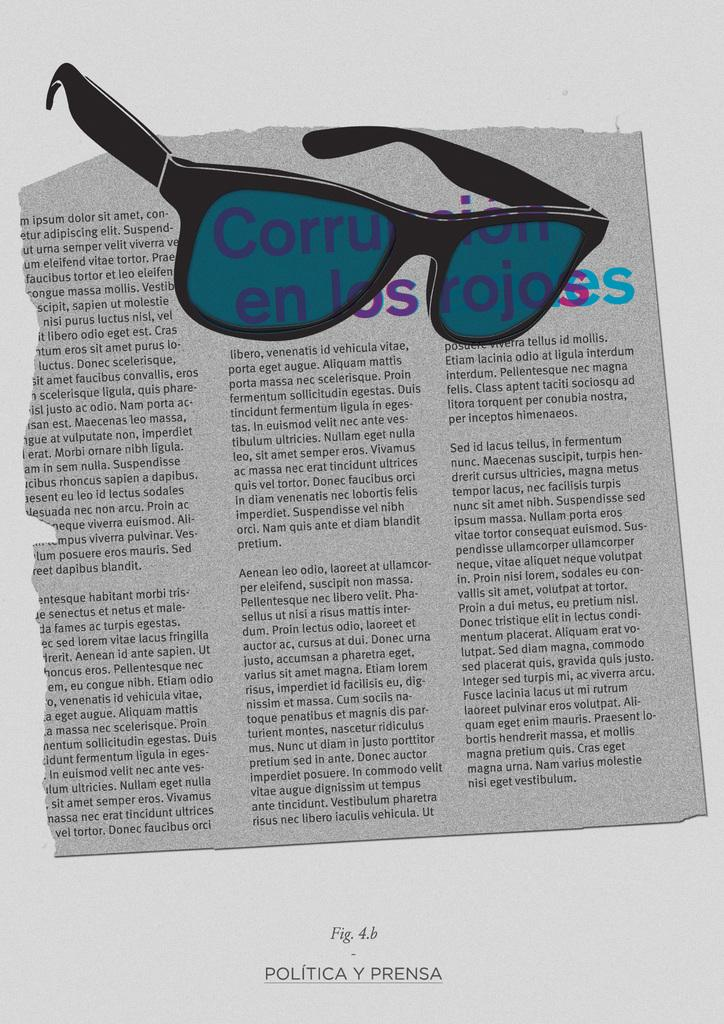What is the main subject of the image? The main subject of the image is a paper. What can be seen on the paper? There is text visible on the paper. Are there any objects present in the image besides the paper? Yes, goggles are present in the image. What type of holiday is being celebrated in the image? There is no indication of a holiday being celebrated in the image, as it features a paper with text and goggles. Can you see any bubbles in the image? There are no bubbles present in the image. 